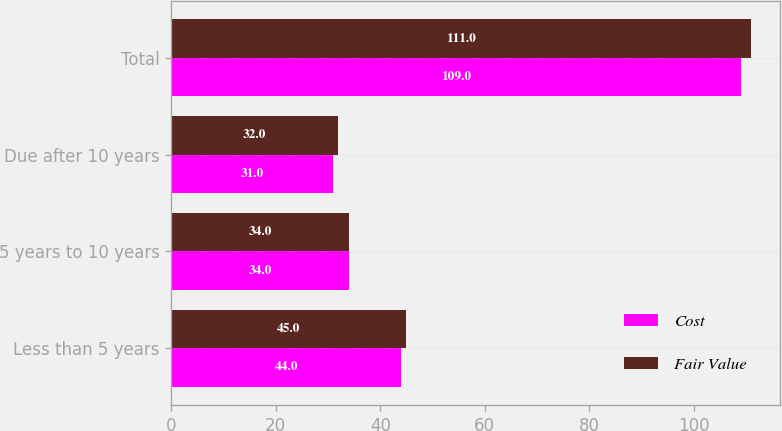Convert chart to OTSL. <chart><loc_0><loc_0><loc_500><loc_500><stacked_bar_chart><ecel><fcel>Less than 5 years<fcel>5 years to 10 years<fcel>Due after 10 years<fcel>Total<nl><fcel>Cost<fcel>44<fcel>34<fcel>31<fcel>109<nl><fcel>Fair Value<fcel>45<fcel>34<fcel>32<fcel>111<nl></chart> 